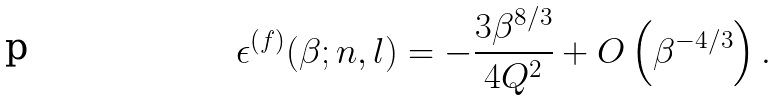<formula> <loc_0><loc_0><loc_500><loc_500>\epsilon ^ { ( f ) } ( \beta ; n , l ) = - \frac { 3 \beta ^ { 8 / 3 } } { 4 Q ^ { 2 } } + O \left ( \beta ^ { - 4 / 3 } \right ) .</formula> 